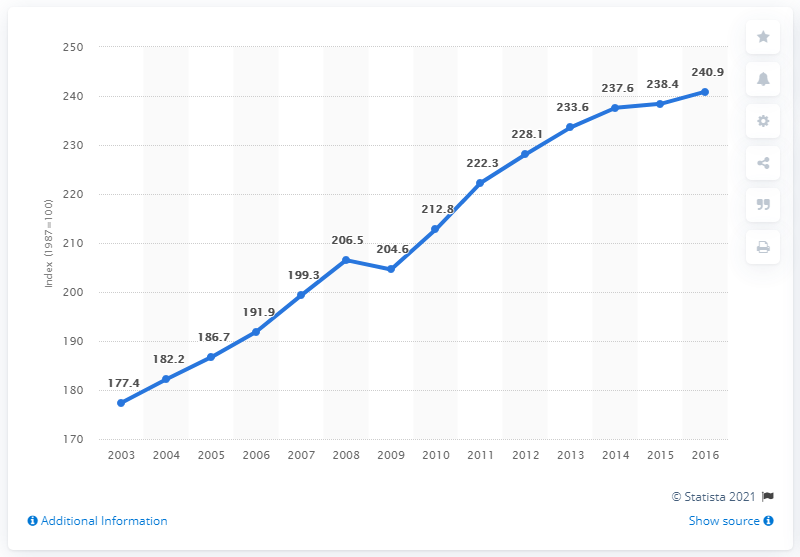Outline some significant characteristics in this image. The line chart indicates a movement of 63.5 points from 2003 to 2016. The data for 2009 is 204.6. 